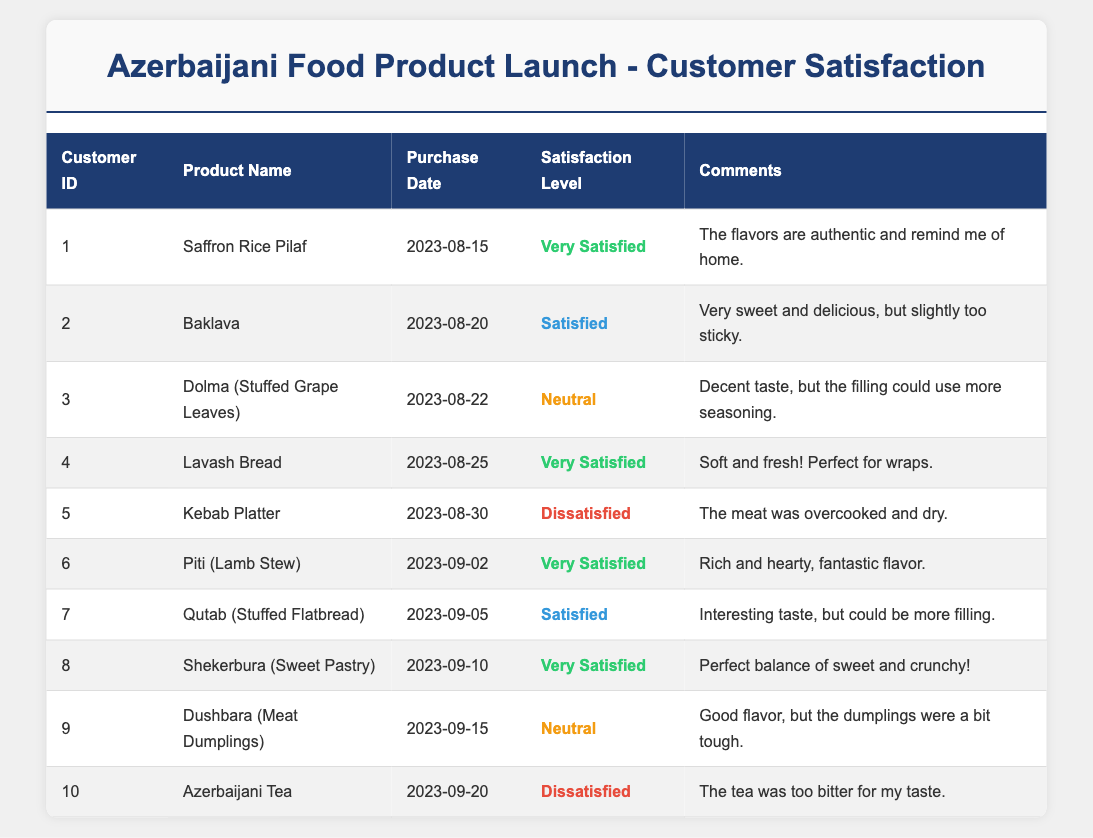What is the highest customer satisfaction level recorded in the table? The highest customer satisfaction level is "Very Satisfied." This is represented by customers 1, 4, 6, and 8 in the table, who all expressed this level of satisfaction for their respective products.
Answer: Very Satisfied How many customers reported being "Dissatisfied"? Two customers reported being "Dissatisfied," specifically customers 5 and 10 in the table.
Answer: 2 Which product received a "Neutral" satisfaction rating? The products that received a "Neutral" rating are "Dolma (Stuffed Grape Leaves)" from customer 3 and "Dushbara (Meat Dumplings)" from customer 9.
Answer: Dolma (Stuffed Grape Leaves) and Dushbara (Meat Dumplings) What percentage of customers were "Very Satisfied"? To calculate the percentage of "Very Satisfied" customers, we count the four customers who rated that way (1, 4, 6, and 8) out of a total of 10 customers. The calculation is (4/10) * 100 = 40%.
Answer: 40% Has any customer left a comment indicating they loved the product? Yes, customer 1 commented that "The flavors are authentic and remind me of home," indicating a strong positive feeling toward the product.
Answer: Yes What is the average satisfaction level of the products based on customer reports? To find the average, assign numerical values to each satisfaction level (Very Satisfied = 4, Satisfied = 3, Neutral = 2, Dissatisfied = 1). The total score is (4 + 3 + 2 + 4 + 1 + 4 + 3 + 4 + 2 + 1) = 28. There are 10 customers, so the average satisfaction level is 28 / 10 = 2.8, which corresponds to a satisfaction level between "Neutral" and "Satisfied."
Answer: 2.8 Which product had the most recent purchase date, and what was the satisfaction level? The most recent purchase date is "2023-09-20," which corresponds to "Azerbaijani Tea" from customer 10, who reported a satisfaction level of "Dissatisfied."
Answer: Azerbaijani Tea, Dissatisfied Count the total number of "Satisfied" customers. There are three customers who reported "Satisfied," specifically customers 2, 7, and 9.
Answer: 3 Did any customers mention that the food product was sticky? Yes, customer 2 mentioned that the Baklava was "very sweet and delicious, but slightly too sticky."
Answer: Yes 